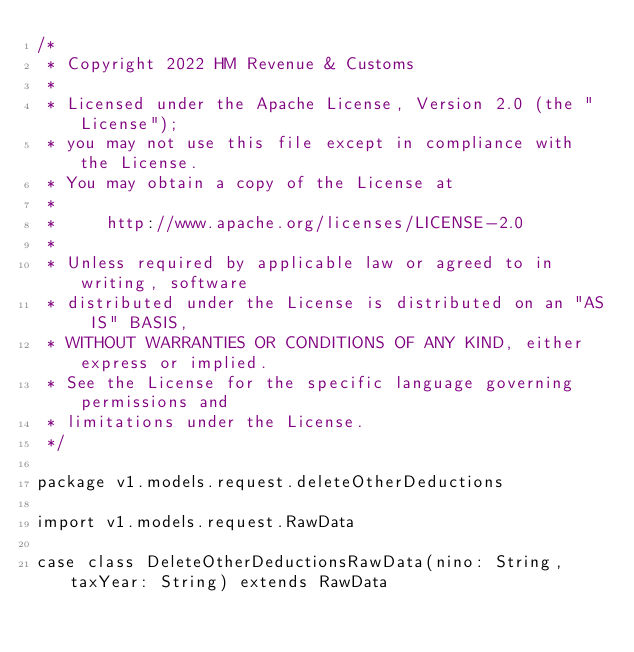Convert code to text. <code><loc_0><loc_0><loc_500><loc_500><_Scala_>/*
 * Copyright 2022 HM Revenue & Customs
 *
 * Licensed under the Apache License, Version 2.0 (the "License");
 * you may not use this file except in compliance with the License.
 * You may obtain a copy of the License at
 *
 *     http://www.apache.org/licenses/LICENSE-2.0
 *
 * Unless required by applicable law or agreed to in writing, software
 * distributed under the License is distributed on an "AS IS" BASIS,
 * WITHOUT WARRANTIES OR CONDITIONS OF ANY KIND, either express or implied.
 * See the License for the specific language governing permissions and
 * limitations under the License.
 */

package v1.models.request.deleteOtherDeductions

import v1.models.request.RawData

case class DeleteOtherDeductionsRawData(nino: String, taxYear: String) extends RawData
</code> 